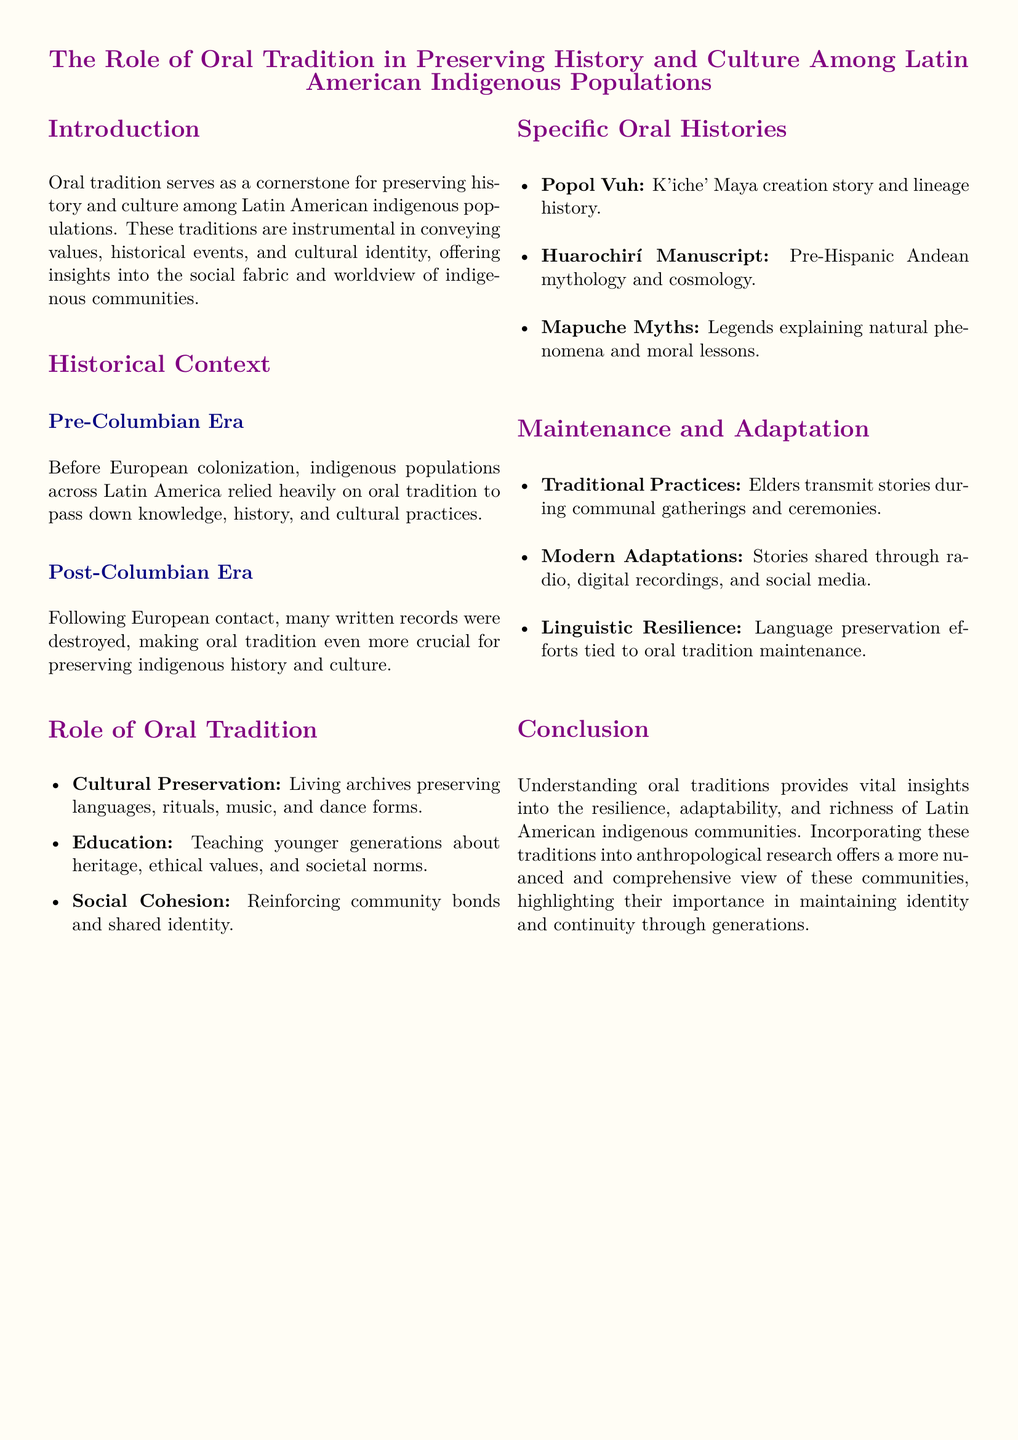what is considered a cornerstone for preserving history among indigenous populations? The document states that oral tradition serves as a cornerstone for preserving history and culture among Latin American indigenous populations.
Answer: oral tradition what significant events impacted the preservation of oral tradition? The document highlights that after European contact, many written records were destroyed, increasing the importance of oral tradition.
Answer: destruction of written records which ancient text is identified as a K'iche' Maya creation story? The document mentions Popol Vuh as the K'iche' Maya creation story and lineage history.
Answer: Popol Vuh name one pre-Hispanic Andean text mentioned in the document. The document references the Huarochirí Manuscript as a pre-Hispanic Andean mythology and cosmology.
Answer: Huarochirí Manuscript how do elders transmit stories in indigenous communities? It is indicated in the document that elders transmit stories during communal gatherings and ceremonies.
Answer: communal gatherings and ceremonies what modern methods are used to share oral traditions? The document notes that stories are shared through radio, digital recordings, and social media as modern adaptations.
Answer: radio, digital recordings, and social media what role does oral tradition play in social cohesion? The document states that oral tradition reinforces community bonds and shared identity, contributing to social cohesion.
Answer: community bonds and shared identity which aspect of culture does oral tradition help to maintain according to the document? The document highlights that oral tradition aids in maintaining values, historical events, and cultural identity.
Answer: cultural identity what mythological theme do Mapuche legends explain? The document mentions that Mapuche myths explain natural phenomena and moral lessons.
Answer: natural phenomena and moral lessons 